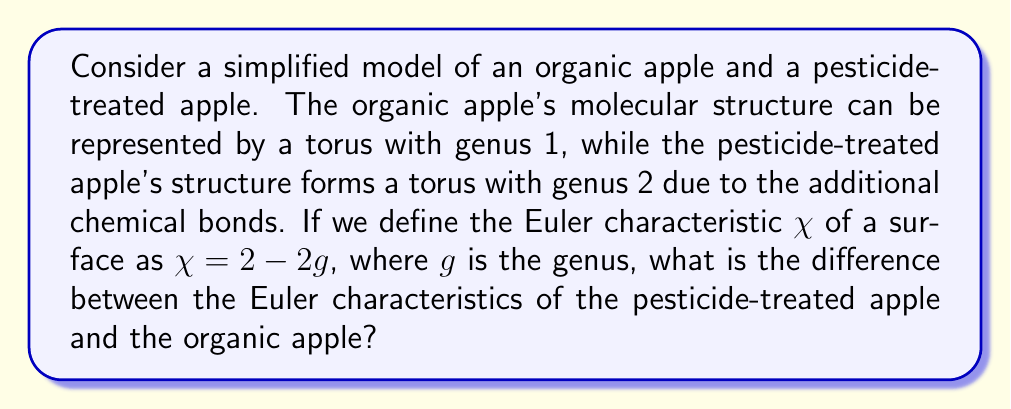Could you help me with this problem? To solve this problem, we need to follow these steps:

1. Calculate the Euler characteristic of the organic apple (genus 1 torus):
   $$\chi_{organic} = 2 - 2g_{organic}$$
   $$\chi_{organic} = 2 - 2(1) = 0$$

2. Calculate the Euler characteristic of the pesticide-treated apple (genus 2 torus):
   $$\chi_{pesticide} = 2 - 2g_{pesticide}$$
   $$\chi_{pesticide} = 2 - 2(2) = -2$$

3. Find the difference between the Euler characteristics:
   $$\Delta\chi = \chi_{pesticide} - \chi_{organic}$$
   $$\Delta\chi = -2 - 0 = -2$$

This negative difference indicates that the pesticide-treated apple's molecular structure is more complex topologically, which could be related to the additional chemical bonds formed by the pesticides. From a nutritionist's perspective, this topological difference might correspond to potential changes in the food's nutritional properties or the presence of residual pesticides that could impact health.
Answer: $-2$ 